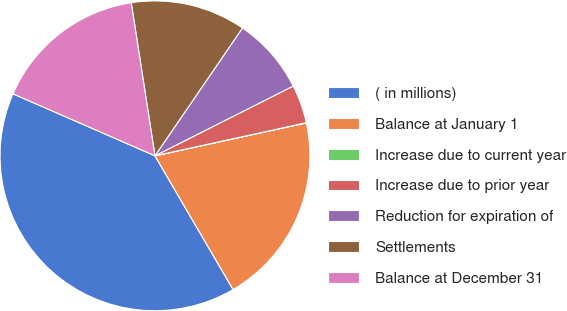<chart> <loc_0><loc_0><loc_500><loc_500><pie_chart><fcel>( in millions)<fcel>Balance at January 1<fcel>Increase due to current year<fcel>Increase due to prior year<fcel>Reduction for expiration of<fcel>Settlements<fcel>Balance at December 31<nl><fcel>39.97%<fcel>19.99%<fcel>0.02%<fcel>4.01%<fcel>8.01%<fcel>12.0%<fcel>16.0%<nl></chart> 